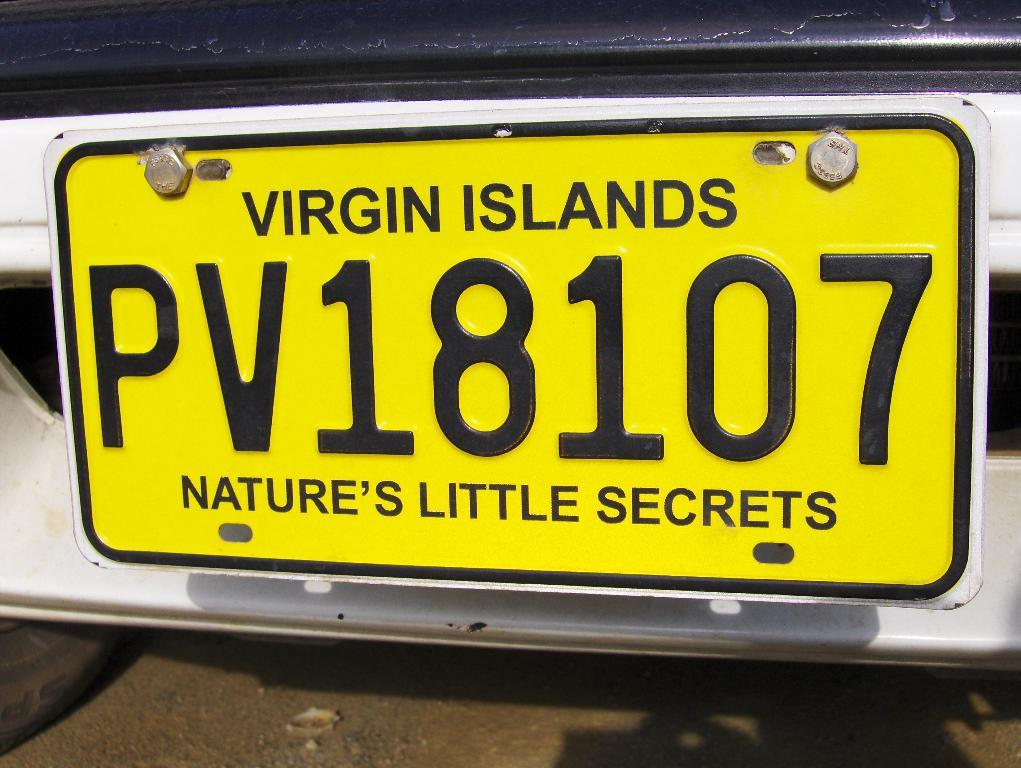<image>
Summarize the visual content of the image. A white car has a yellow license plate that says Virgin Islands Nature's Little Secrets. 